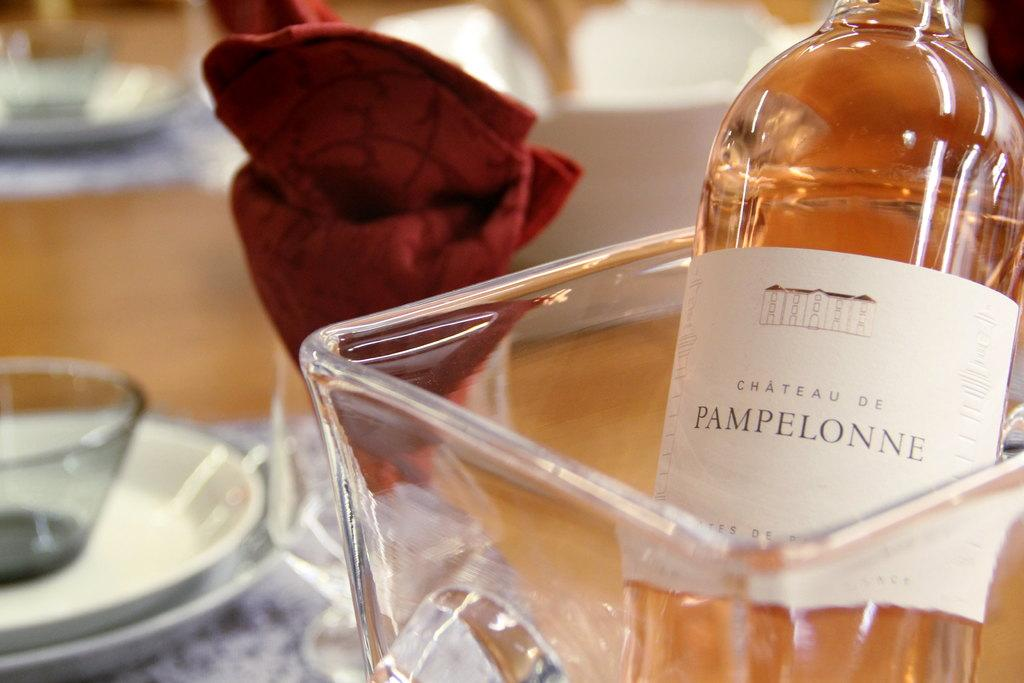<image>
Relay a brief, clear account of the picture shown. A bottle of wine from Chateau de Pampelonne is chilling in a glass jar next to a red napkin folded into a flower shape. 